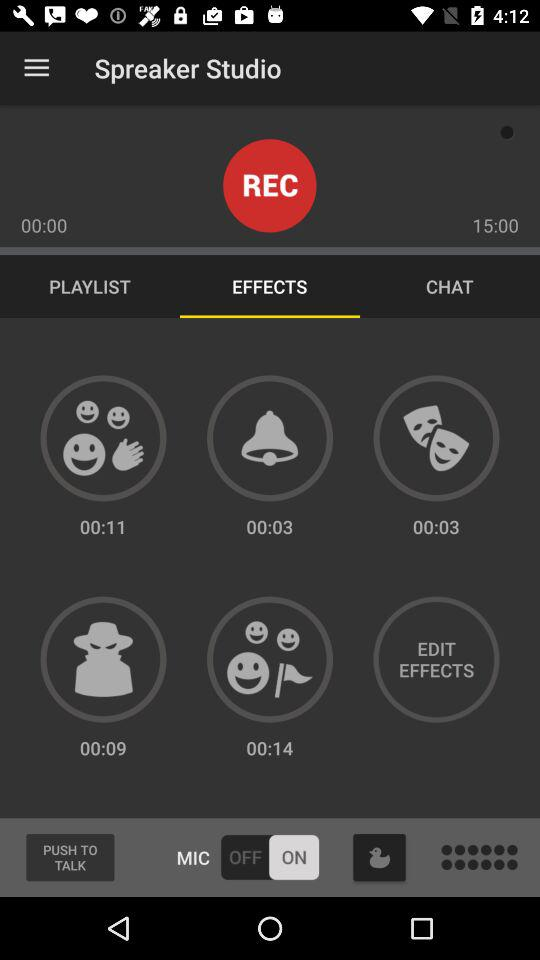What is the overall recording time? The overall recording time is 15 minutes. 